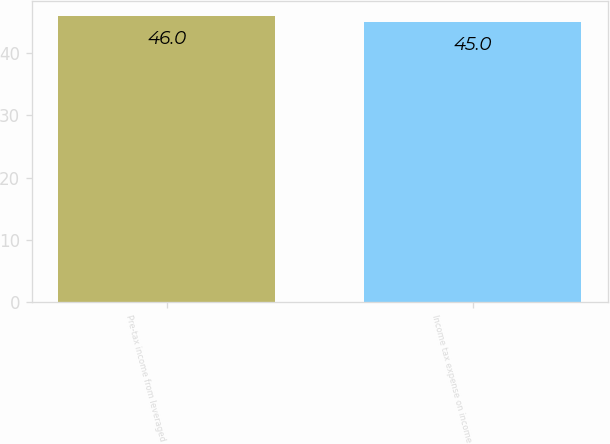<chart> <loc_0><loc_0><loc_500><loc_500><bar_chart><fcel>Pre-tax income from leveraged<fcel>Income tax expense on income<nl><fcel>46<fcel>45<nl></chart> 